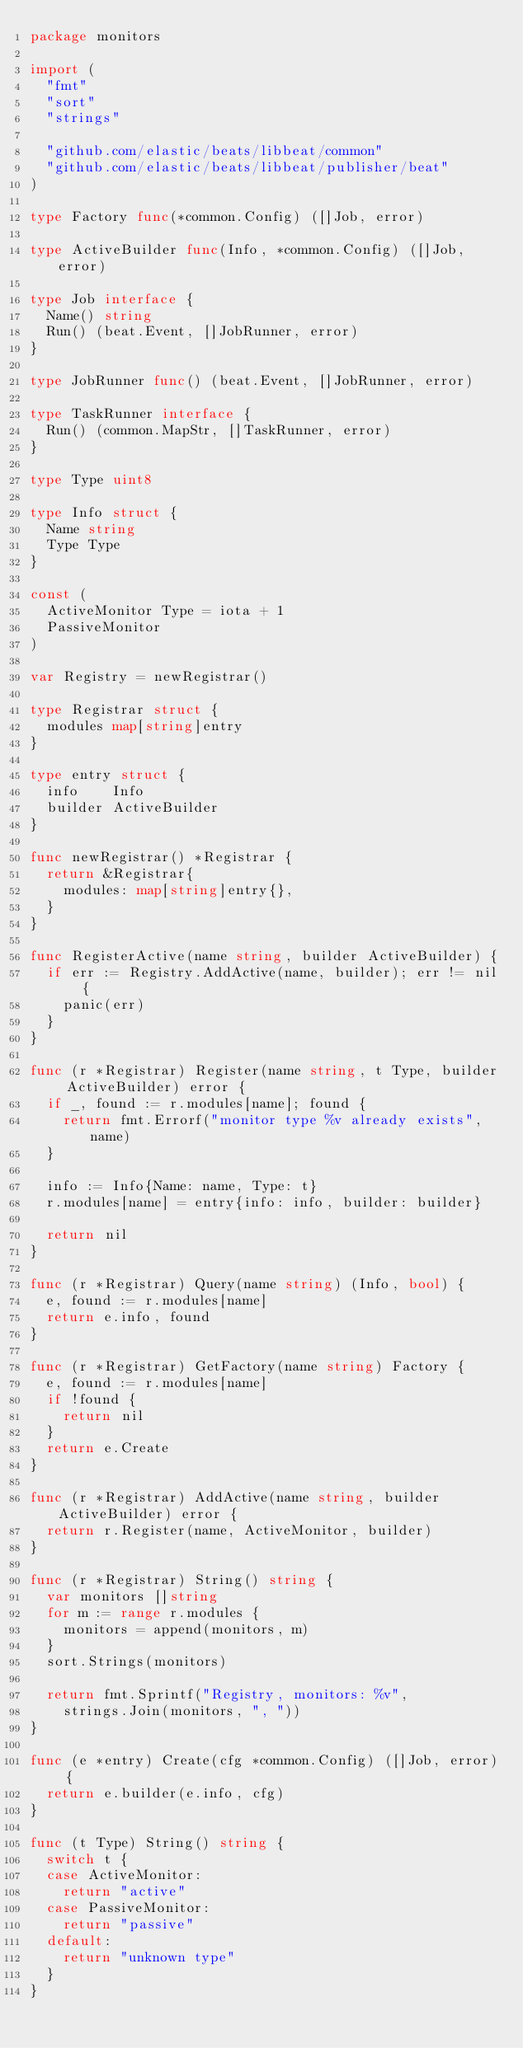Convert code to text. <code><loc_0><loc_0><loc_500><loc_500><_Go_>package monitors

import (
	"fmt"
	"sort"
	"strings"

	"github.com/elastic/beats/libbeat/common"
	"github.com/elastic/beats/libbeat/publisher/beat"
)

type Factory func(*common.Config) ([]Job, error)

type ActiveBuilder func(Info, *common.Config) ([]Job, error)

type Job interface {
	Name() string
	Run() (beat.Event, []JobRunner, error)
}

type JobRunner func() (beat.Event, []JobRunner, error)

type TaskRunner interface {
	Run() (common.MapStr, []TaskRunner, error)
}

type Type uint8

type Info struct {
	Name string
	Type Type
}

const (
	ActiveMonitor Type = iota + 1
	PassiveMonitor
)

var Registry = newRegistrar()

type Registrar struct {
	modules map[string]entry
}

type entry struct {
	info    Info
	builder ActiveBuilder
}

func newRegistrar() *Registrar {
	return &Registrar{
		modules: map[string]entry{},
	}
}

func RegisterActive(name string, builder ActiveBuilder) {
	if err := Registry.AddActive(name, builder); err != nil {
		panic(err)
	}
}

func (r *Registrar) Register(name string, t Type, builder ActiveBuilder) error {
	if _, found := r.modules[name]; found {
		return fmt.Errorf("monitor type %v already exists", name)
	}

	info := Info{Name: name, Type: t}
	r.modules[name] = entry{info: info, builder: builder}

	return nil
}

func (r *Registrar) Query(name string) (Info, bool) {
	e, found := r.modules[name]
	return e.info, found
}

func (r *Registrar) GetFactory(name string) Factory {
	e, found := r.modules[name]
	if !found {
		return nil
	}
	return e.Create
}

func (r *Registrar) AddActive(name string, builder ActiveBuilder) error {
	return r.Register(name, ActiveMonitor, builder)
}

func (r *Registrar) String() string {
	var monitors []string
	for m := range r.modules {
		monitors = append(monitors, m)
	}
	sort.Strings(monitors)

	return fmt.Sprintf("Registry, monitors: %v",
		strings.Join(monitors, ", "))
}

func (e *entry) Create(cfg *common.Config) ([]Job, error) {
	return e.builder(e.info, cfg)
}

func (t Type) String() string {
	switch t {
	case ActiveMonitor:
		return "active"
	case PassiveMonitor:
		return "passive"
	default:
		return "unknown type"
	}
}
</code> 